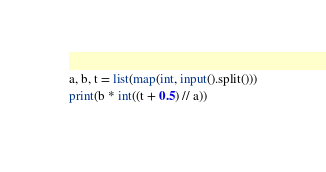<code> <loc_0><loc_0><loc_500><loc_500><_Python_>a, b, t = list(map(int, input().split()))
print(b * int((t + 0.5) // a))</code> 